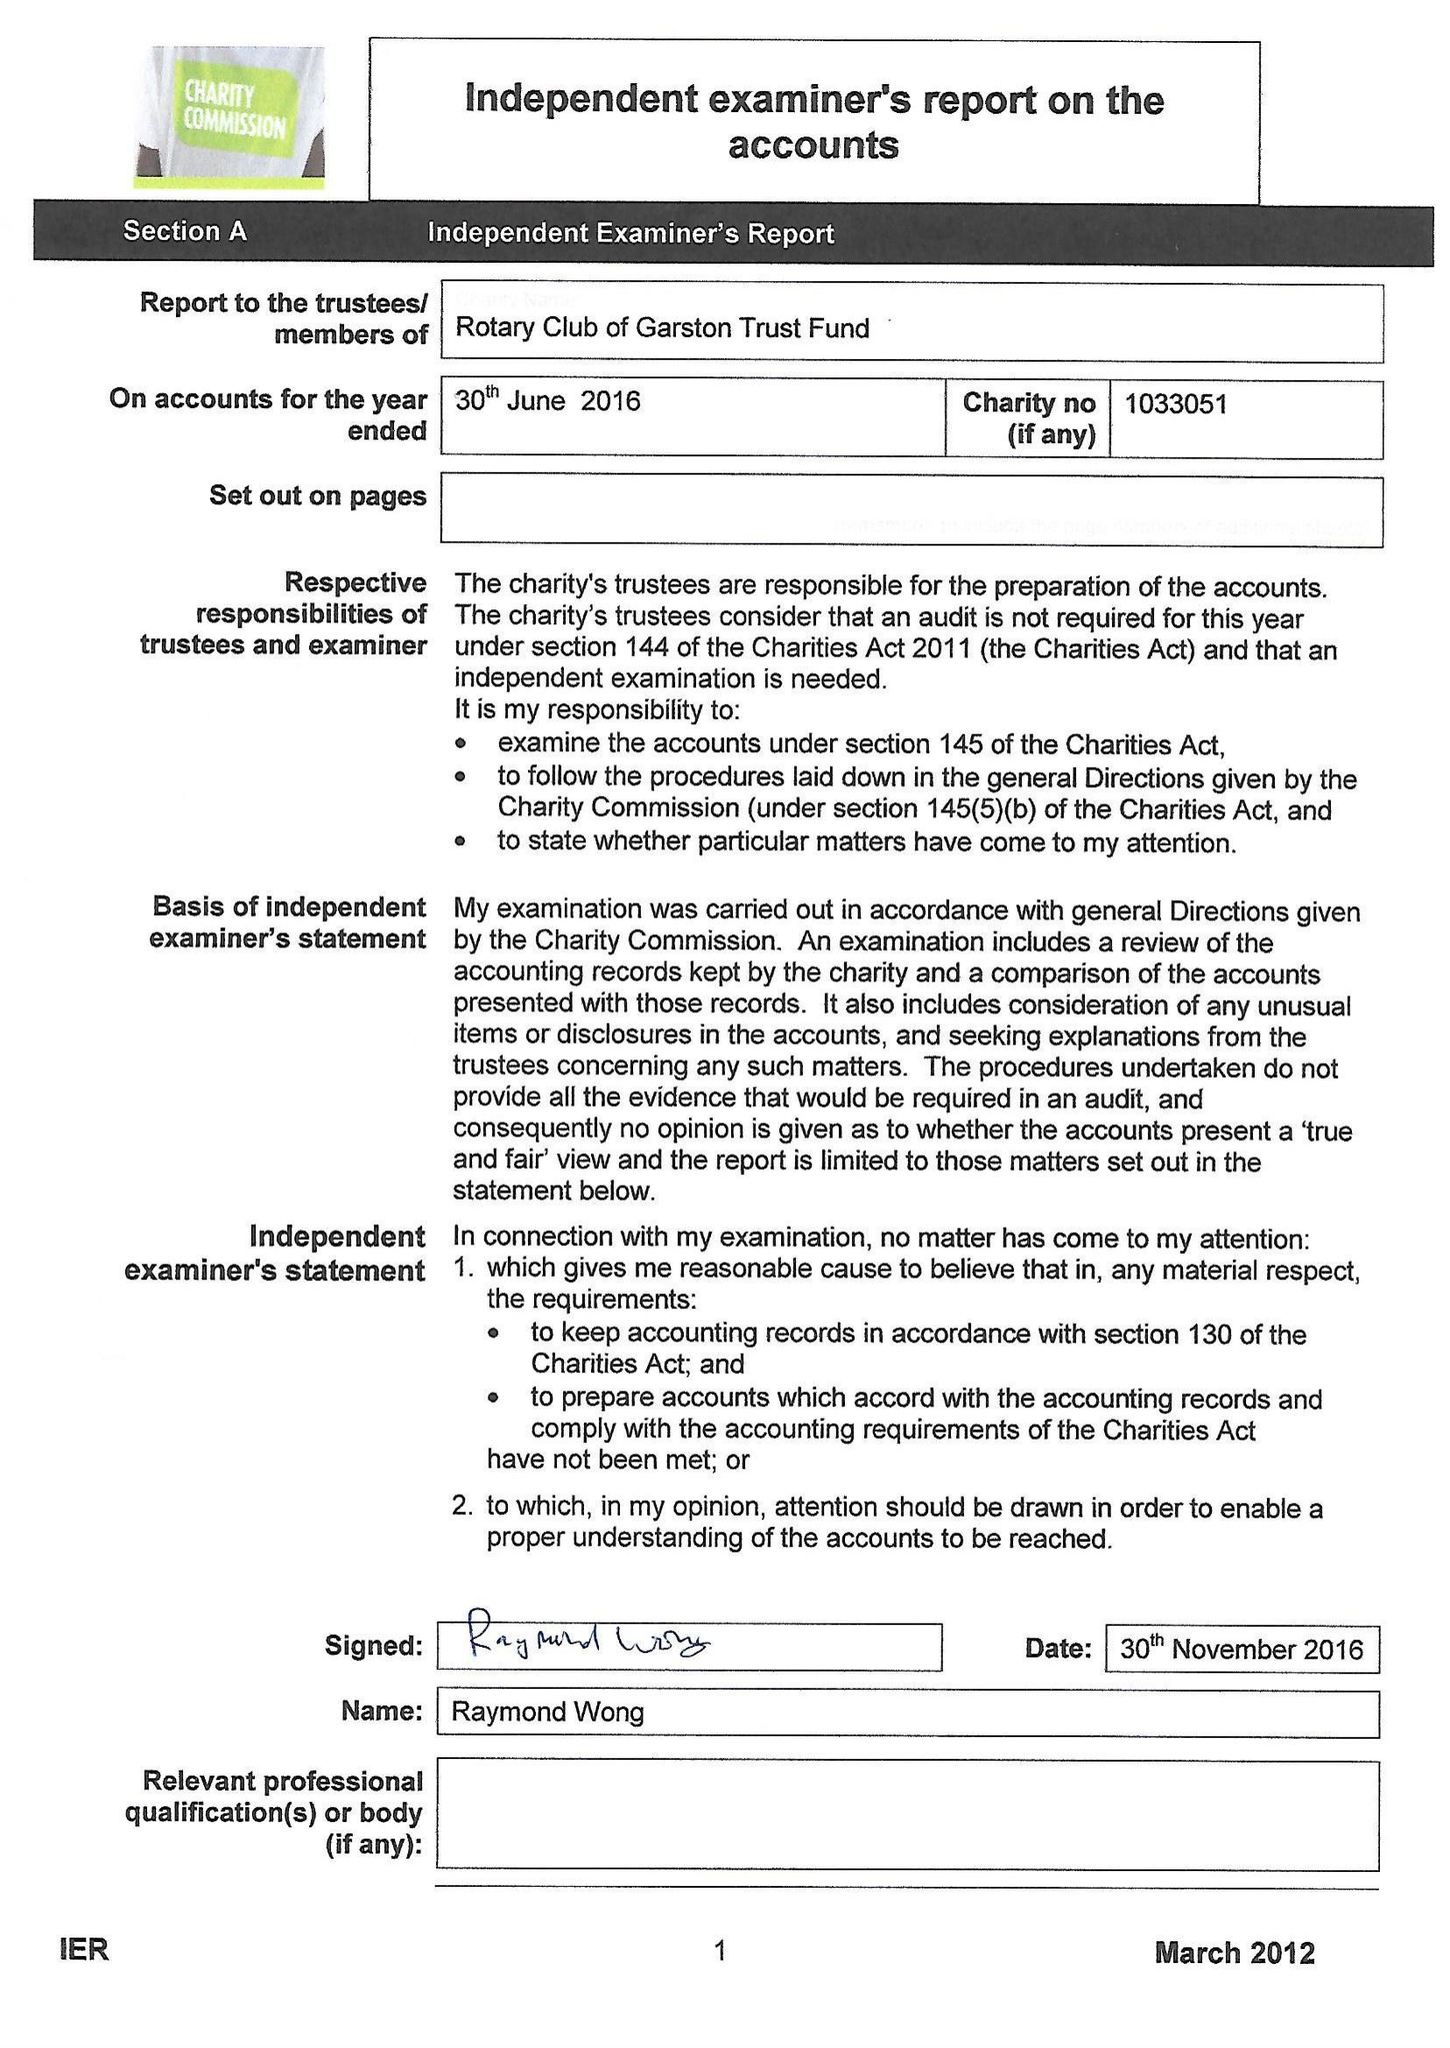What is the value for the address__post_town?
Answer the question using a single word or phrase. LIVERPOOL 